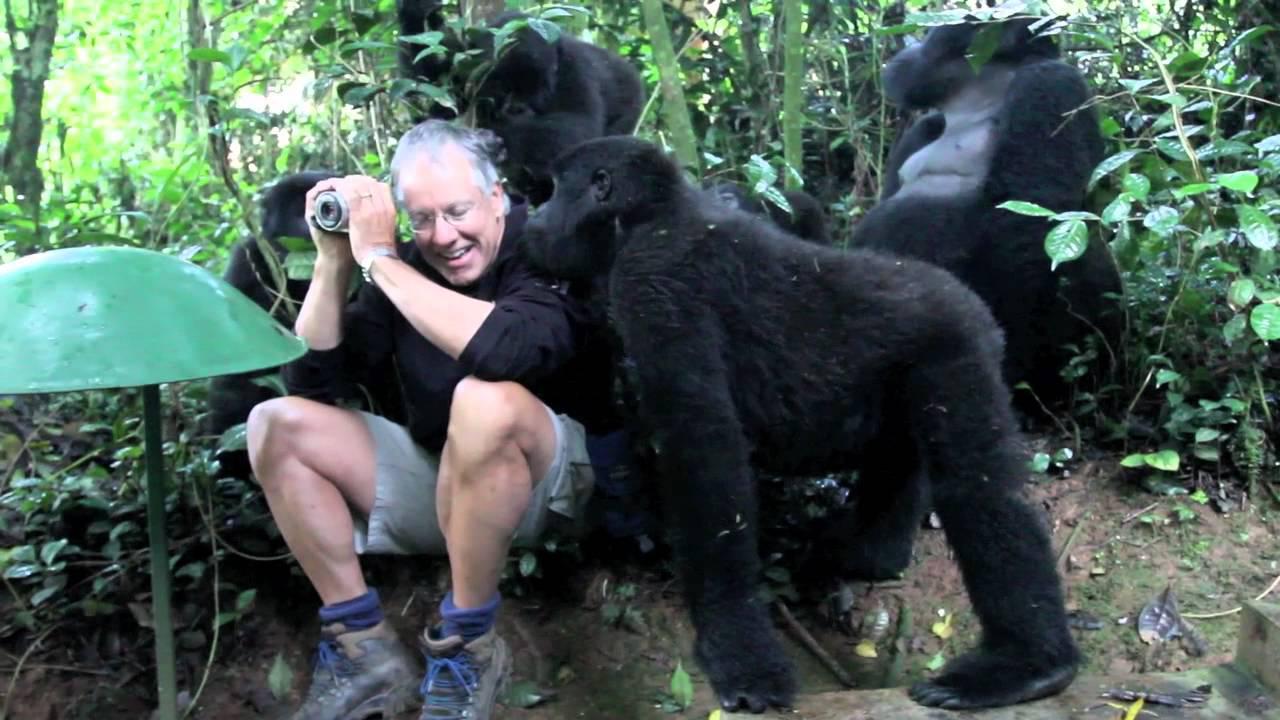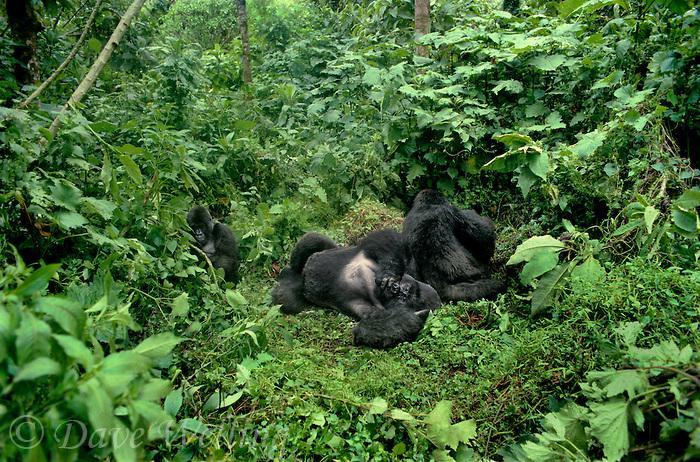The first image is the image on the left, the second image is the image on the right. Examine the images to the left and right. Is the description "One primate is carrying a younger primate." accurate? Answer yes or no. No. The first image is the image on the left, the second image is the image on the right. For the images shown, is this caption "One image shows just one gorilla, a male on all fours with its body turned leftward, and the other image contains two apes, one a tiny baby." true? Answer yes or no. No. 